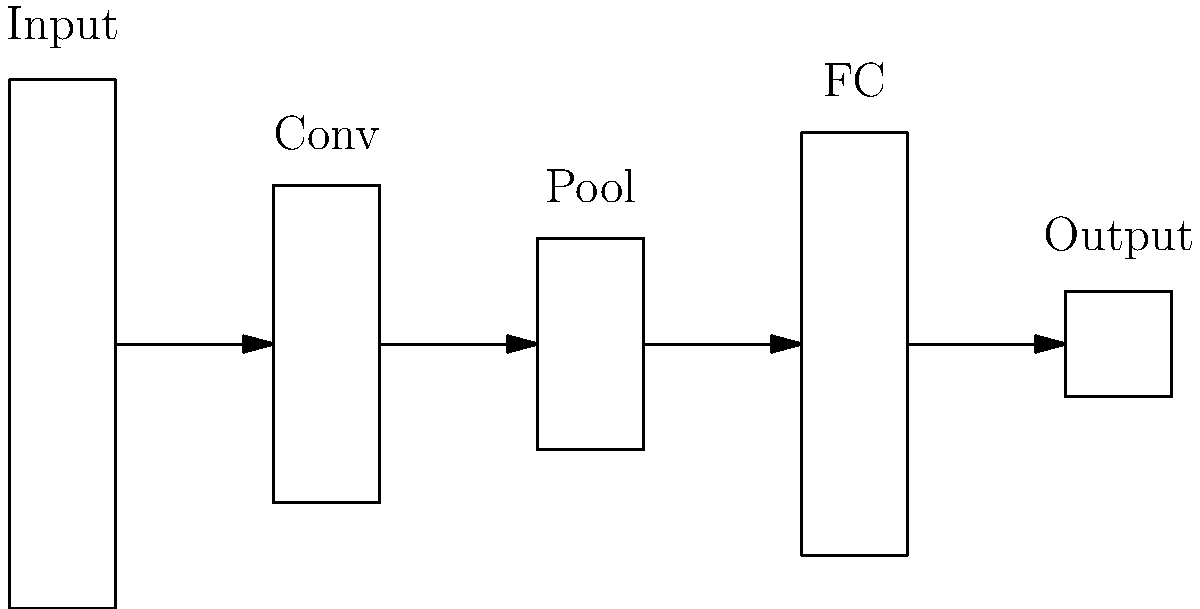In the given CNN architecture diagram, which layer is responsible for reducing the spatial dimensions of the feature maps while retaining the most important information? To answer this question, let's analyze the components of the CNN architecture shown in the diagram:

1. Input layer: This is where the raw input data (e.g., images) enters the network.

2. Convolutional layer (Conv): This layer applies filters to the input to extract features. It doesn't reduce spatial dimensions significantly.

3. Pooling layer (Pool): This layer is specifically designed to reduce the spatial dimensions of the feature maps. It does this by:
   a) Summarizing features in local regions (e.g., taking the maximum or average value).
   b) Reducing the size of the feature maps, typically by a factor of 2 in each dimension.
   c) Retaining the most important information while discarding less relevant details.

4. Fully connected layer (FC): This layer connects every neuron from the previous layer to every neuron in the next layer. It doesn't deal with spatial dimensions directly.

5. Output layer: This layer provides the final output of the network.

Among these layers, the Pooling layer is specifically responsible for reducing spatial dimensions while preserving important features. It helps in:
- Reducing computational complexity
- Providing a form of translation invariance
- Controlling overfitting by reducing the number of parameters in the network

Therefore, the Pooling layer is the correct answer to this question.
Answer: Pooling layer 